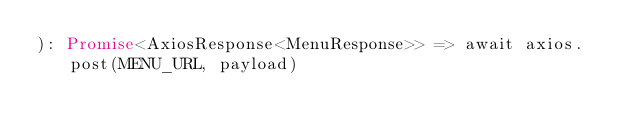Convert code to text. <code><loc_0><loc_0><loc_500><loc_500><_TypeScript_>): Promise<AxiosResponse<MenuResponse>> => await axios.post(MENU_URL, payload)
</code> 